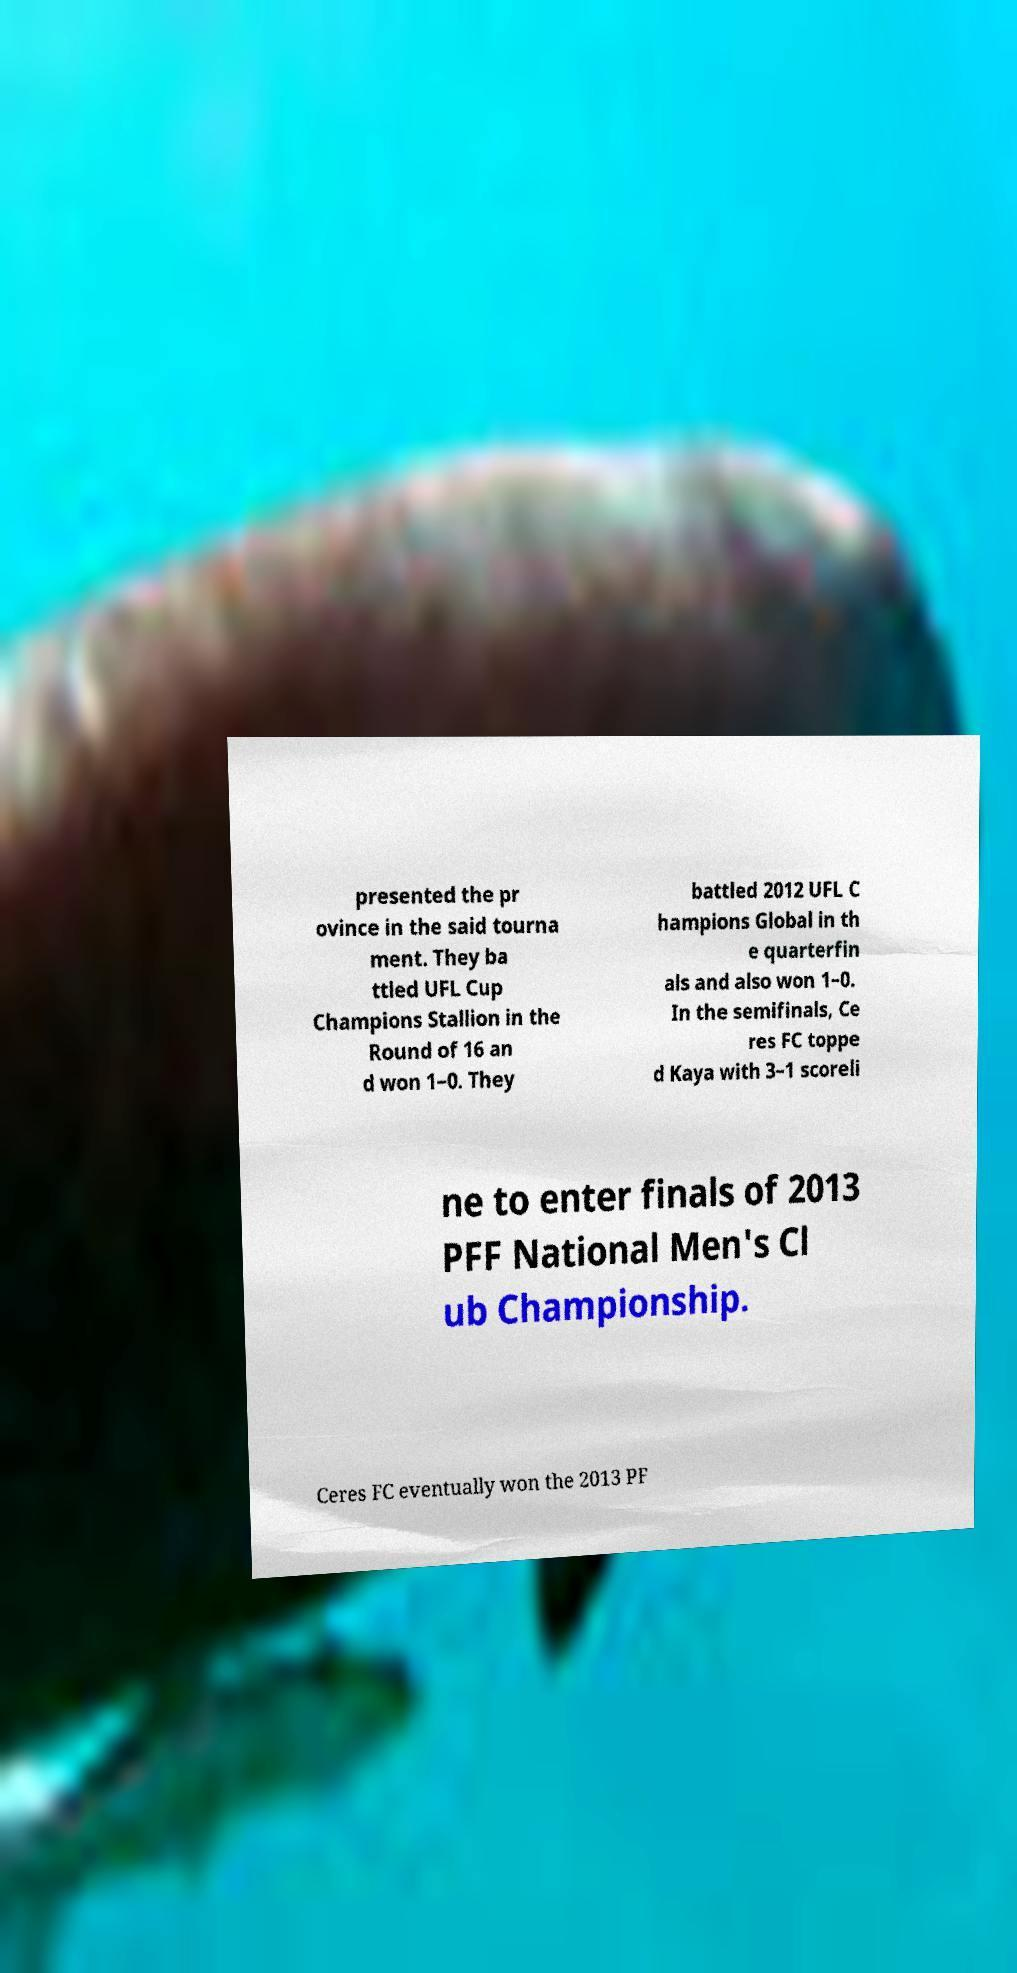Could you extract and type out the text from this image? presented the pr ovince in the said tourna ment. They ba ttled UFL Cup Champions Stallion in the Round of 16 an d won 1–0. They battled 2012 UFL C hampions Global in th e quarterfin als and also won 1–0. In the semifinals, Ce res FC toppe d Kaya with 3–1 scoreli ne to enter finals of 2013 PFF National Men's Cl ub Championship. Ceres FC eventually won the 2013 PF 